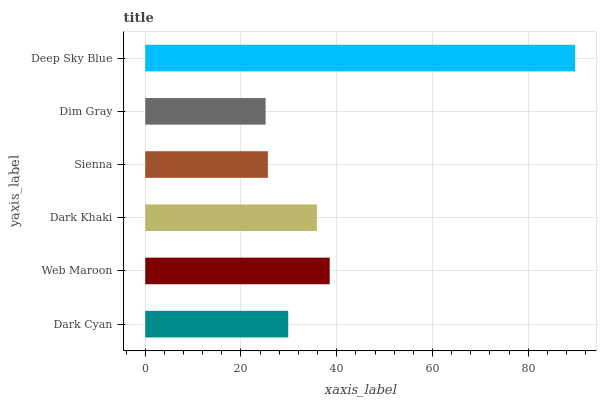Is Dim Gray the minimum?
Answer yes or no. Yes. Is Deep Sky Blue the maximum?
Answer yes or no. Yes. Is Web Maroon the minimum?
Answer yes or no. No. Is Web Maroon the maximum?
Answer yes or no. No. Is Web Maroon greater than Dark Cyan?
Answer yes or no. Yes. Is Dark Cyan less than Web Maroon?
Answer yes or no. Yes. Is Dark Cyan greater than Web Maroon?
Answer yes or no. No. Is Web Maroon less than Dark Cyan?
Answer yes or no. No. Is Dark Khaki the high median?
Answer yes or no. Yes. Is Dark Cyan the low median?
Answer yes or no. Yes. Is Sienna the high median?
Answer yes or no. No. Is Sienna the low median?
Answer yes or no. No. 